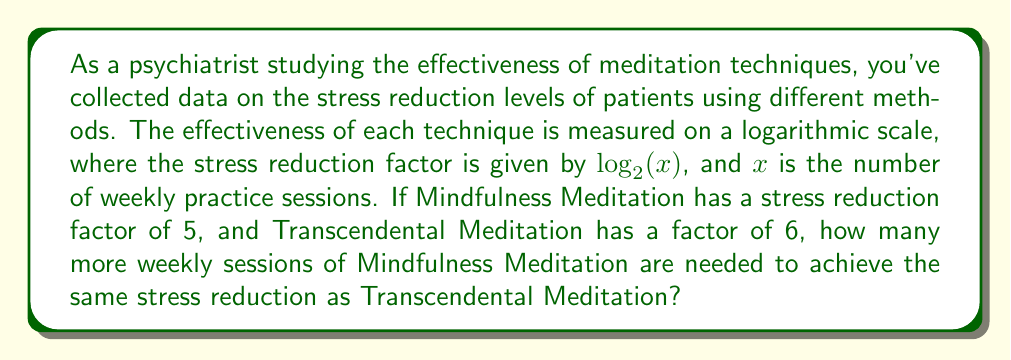Provide a solution to this math problem. Let's approach this step-by-step:

1) For Mindfulness Meditation (MM):
   $\log_2(x_{MM}) = 5$

2) For Transcendental Meditation (TM):
   $\log_2(x_{TM}) = 6$

3) We need to solve for $x_{MM}$ and $x_{TM}$:

   For MM: $2^5 = x_{MM}$, so $x_{MM} = 32$
   For TM: $2^6 = x_{TM}$, so $x_{TM} = 64$

4) The difference in weekly sessions is:
   $x_{TM} - x_{MM} = 64 - 32 = 32$

Therefore, 32 more weekly sessions of Mindfulness Meditation are needed to achieve the same stress reduction as Transcendental Meditation.
Answer: 32 sessions 